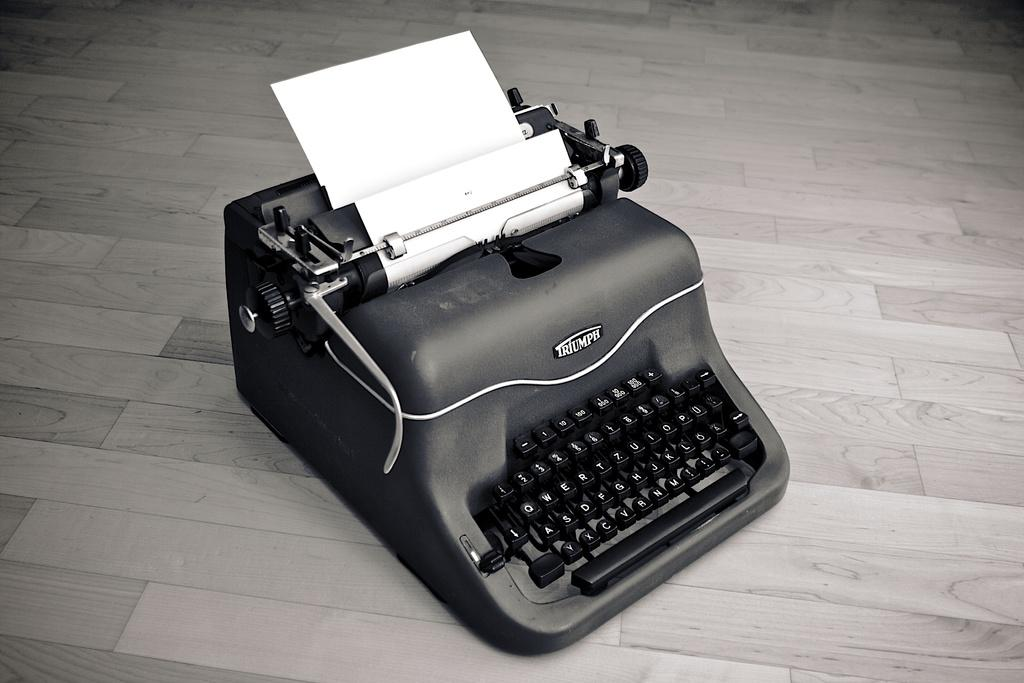Provide a one-sentence caption for the provided image. An old fashioned black typewriter by Triumph with a piece of white paper in the typewriter. 